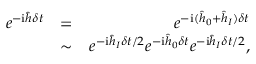Convert formula to latex. <formula><loc_0><loc_0><loc_500><loc_500>\begin{array} { r l r } { e ^ { - i \hat { h } \delta t } } & { = } & { e ^ { - i ( \hat { h } _ { 0 } + \hat { h } _ { I } ) \delta t } } \\ & { \sim } & { e ^ { - i \hat { h } _ { I } \delta t / 2 } e ^ { - i \hat { h } _ { 0 } \delta t } e ^ { - i \hat { h } _ { I } \delta t / 2 } , } \end{array}</formula> 